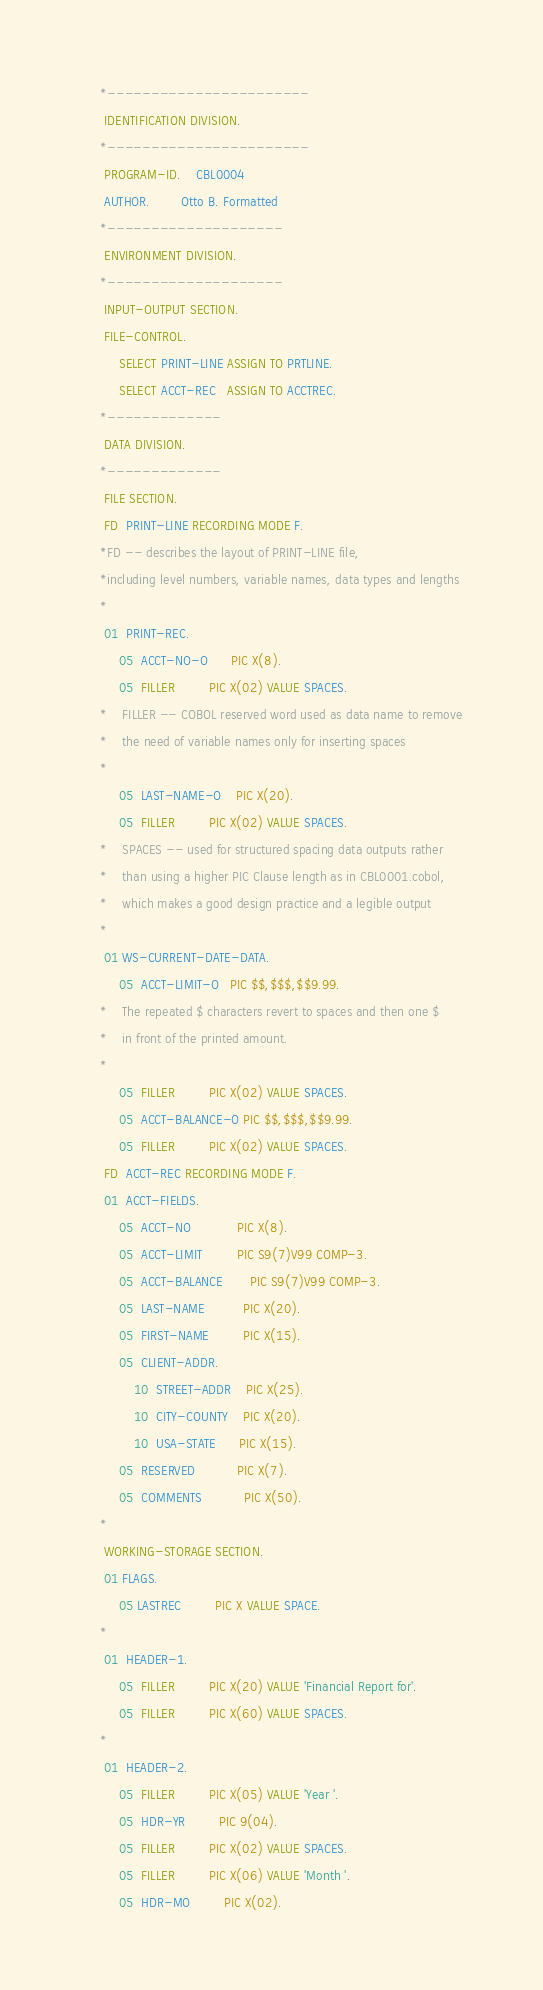<code> <loc_0><loc_0><loc_500><loc_500><_COBOL_>      *-----------------------
       IDENTIFICATION DIVISION.
      *-----------------------
       PROGRAM-ID.    CBL0004
       AUTHOR.        Otto B. Formatted
      *--------------------
       ENVIRONMENT DIVISION.
      *--------------------
       INPUT-OUTPUT SECTION.
       FILE-CONTROL.
           SELECT PRINT-LINE ASSIGN TO PRTLINE.
           SELECT ACCT-REC   ASSIGN TO ACCTREC.
      *-------------
       DATA DIVISION.
      *-------------
       FILE SECTION.
       FD  PRINT-LINE RECORDING MODE F.
      *FD -- describes the layout of PRINT-LINE file,
      *including level numbers, variable names, data types and lengths
      *
       01  PRINT-REC.
           05  ACCT-NO-O      PIC X(8).
           05  FILLER         PIC X(02) VALUE SPACES.
      *    FILLER -- COBOL reserved word used as data name to remove 
      *    the need of variable names only for inserting spaces
      *
           05  LAST-NAME-O    PIC X(20).
           05  FILLER         PIC X(02) VALUE SPACES.
      *    SPACES -- used for structured spacing data outputs rather
      *    than using a higher PIC Clause length as in CBL0001.cobol,
      *    which makes a good design practice and a legible output
      *
       01 WS-CURRENT-DATE-DATA.
           05  ACCT-LIMIT-O   PIC $$,$$$,$$9.99.
      *    The repeated $ characters revert to spaces and then one $
      *    in front of the printed amount.
      *
           05  FILLER         PIC X(02) VALUE SPACES.
           05  ACCT-BALANCE-O PIC $$,$$$,$$9.99.
           05  FILLER         PIC X(02) VALUE SPACES.
       FD  ACCT-REC RECORDING MODE F.
       01  ACCT-FIELDS.
           05  ACCT-NO            PIC X(8).
           05  ACCT-LIMIT         PIC S9(7)V99 COMP-3.
           05  ACCT-BALANCE       PIC S9(7)V99 COMP-3.
           05  LAST-NAME          PIC X(20).
           05  FIRST-NAME         PIC X(15).
           05  CLIENT-ADDR.
               10  STREET-ADDR    PIC X(25).
               10  CITY-COUNTY    PIC X(20).
               10  USA-STATE      PIC X(15).
           05  RESERVED           PIC X(7).
           05  COMMENTS           PIC X(50).
      *
       WORKING-STORAGE SECTION.
       01 FLAGS.
           05 LASTREC         PIC X VALUE SPACE.
      *
       01  HEADER-1.
           05  FILLER         PIC X(20) VALUE 'Financial Report for'.
           05  FILLER         PIC X(60) VALUE SPACES.
      *
       01  HEADER-2.
           05  FILLER         PIC X(05) VALUE 'Year '.
           05  HDR-YR         PIC 9(04).
           05  FILLER         PIC X(02) VALUE SPACES.
           05  FILLER         PIC X(06) VALUE 'Month '.
           05  HDR-MO         PIC X(02).</code> 